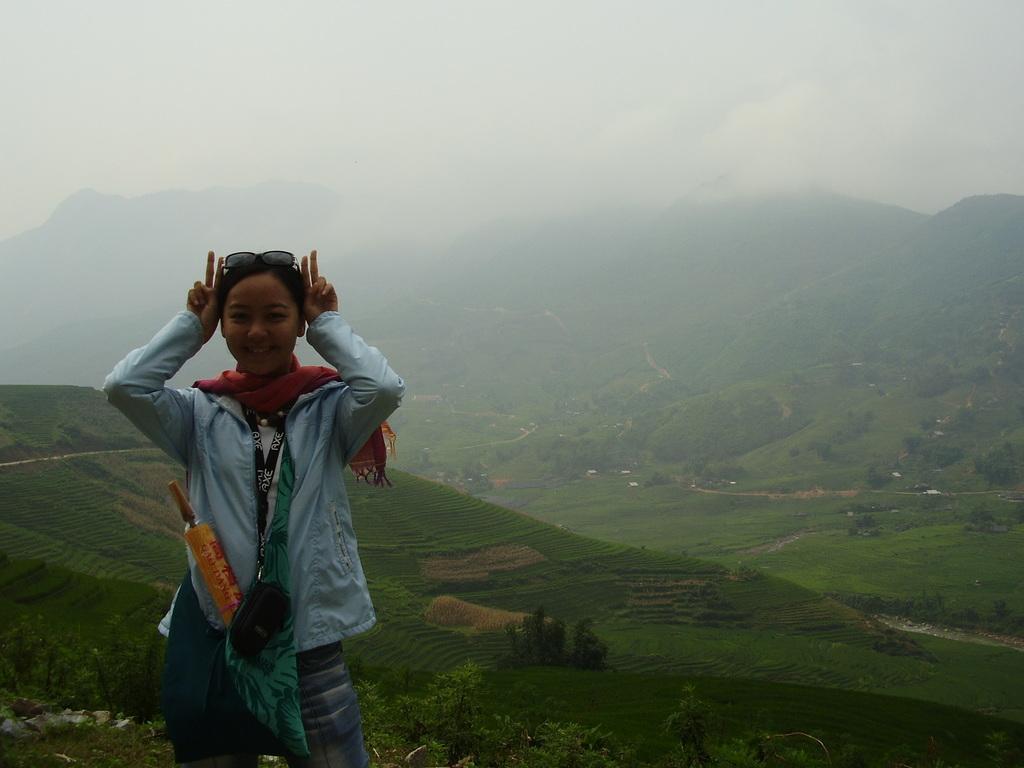In one or two sentences, can you explain what this image depicts? In this image there is a lady standing, in the background there are mountains, trees and fog. 